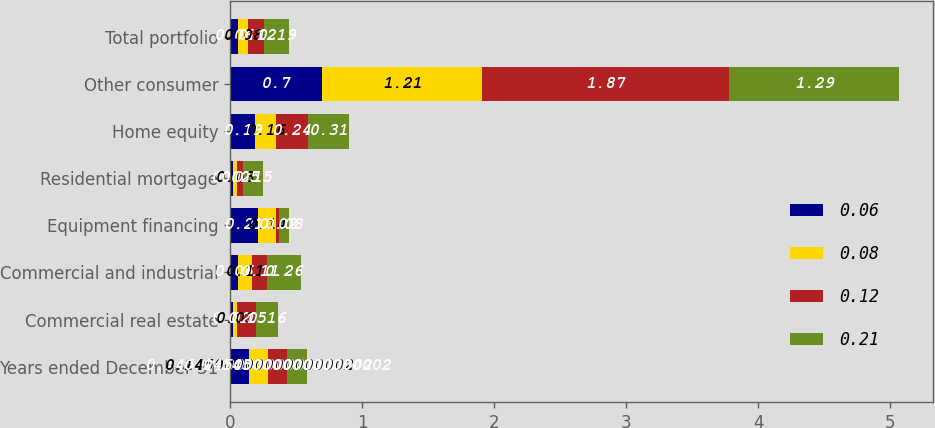Convert chart to OTSL. <chart><loc_0><loc_0><loc_500><loc_500><stacked_bar_chart><ecel><fcel>Years ended December 31<fcel>Commercial real estate<fcel>Commercial and industrial<fcel>Equipment financing<fcel>Residential mortgage<fcel>Home equity<fcel>Other consumer<fcel>Total portfolio<nl><fcel>0.06<fcel>0.145<fcel>0.02<fcel>0.06<fcel>0.21<fcel>0.02<fcel>0.19<fcel>0.7<fcel>0.06<nl><fcel>0.08<fcel>0.145<fcel>0.03<fcel>0.11<fcel>0.14<fcel>0.03<fcel>0.16<fcel>1.21<fcel>0.08<nl><fcel>0.12<fcel>0.145<fcel>0.15<fcel>0.11<fcel>0.02<fcel>0.05<fcel>0.24<fcel>1.87<fcel>0.12<nl><fcel>0.21<fcel>0.145<fcel>0.16<fcel>0.26<fcel>0.08<fcel>0.15<fcel>0.31<fcel>1.29<fcel>0.19<nl></chart> 